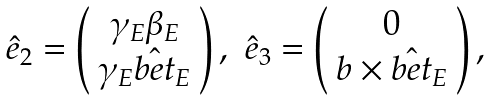<formula> <loc_0><loc_0><loc_500><loc_500>\begin{array} { c c } { \hat { e } } _ { 2 } = \left ( \begin{array} { c } \gamma _ { E } \beta _ { E } \\ \gamma _ { E } { \hat { b e t } } _ { E } \end{array} \right ) , & { \hat { e } } _ { 3 } = \left ( \begin{array} { c } 0 \\ { b } \times { \hat { b e t } } _ { E } \end{array} \right ) , \end{array}</formula> 